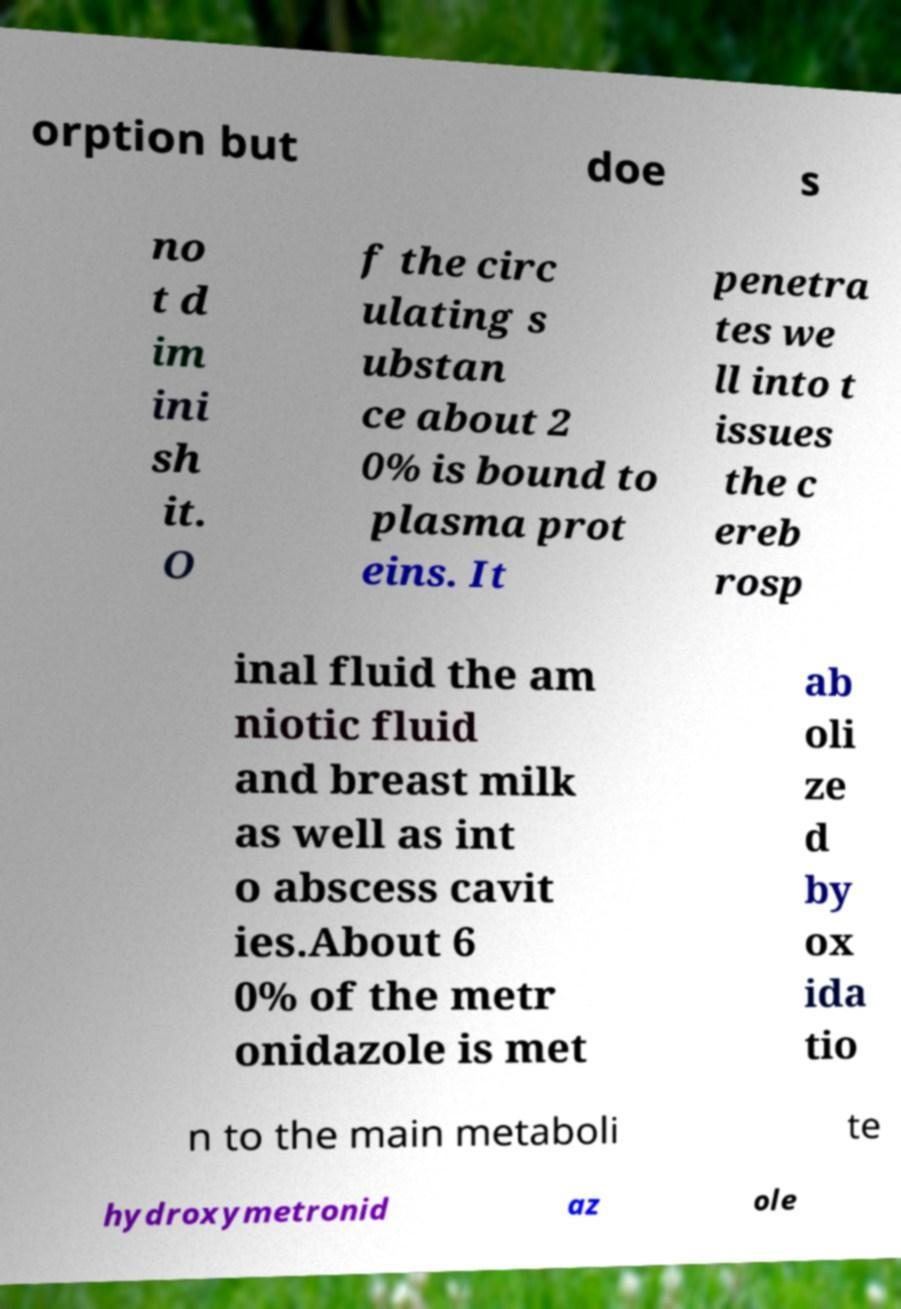Could you extract and type out the text from this image? orption but doe s no t d im ini sh it. O f the circ ulating s ubstan ce about 2 0% is bound to plasma prot eins. It penetra tes we ll into t issues the c ereb rosp inal fluid the am niotic fluid and breast milk as well as int o abscess cavit ies.About 6 0% of the metr onidazole is met ab oli ze d by ox ida tio n to the main metaboli te hydroxymetronid az ole 